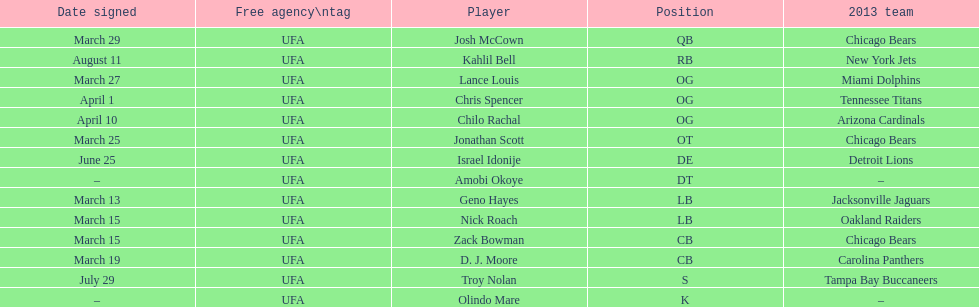Last name is also a first name beginning with "n" Troy Nolan. Would you mind parsing the complete table? {'header': ['Date signed', 'Free agency\\ntag', 'Player', 'Position', '2013 team'], 'rows': [['March 29', 'UFA', 'Josh McCown', 'QB', 'Chicago Bears'], ['August 11', 'UFA', 'Kahlil Bell', 'RB', 'New York Jets'], ['March 27', 'UFA', 'Lance Louis', 'OG', 'Miami Dolphins'], ['April 1', 'UFA', 'Chris Spencer', 'OG', 'Tennessee Titans'], ['April 10', 'UFA', 'Chilo Rachal', 'OG', 'Arizona Cardinals'], ['March 25', 'UFA', 'Jonathan Scott', 'OT', 'Chicago Bears'], ['June 25', 'UFA', 'Israel Idonije', 'DE', 'Detroit Lions'], ['–', 'UFA', 'Amobi Okoye', 'DT', '–'], ['March 13', 'UFA', 'Geno Hayes', 'LB', 'Jacksonville Jaguars'], ['March 15', 'UFA', 'Nick Roach', 'LB', 'Oakland Raiders'], ['March 15', 'UFA', 'Zack Bowman', 'CB', 'Chicago Bears'], ['March 19', 'UFA', 'D. J. Moore', 'CB', 'Carolina Panthers'], ['July 29', 'UFA', 'Troy Nolan', 'S', 'Tampa Bay Buccaneers'], ['–', 'UFA', 'Olindo Mare', 'K', '–']]} 